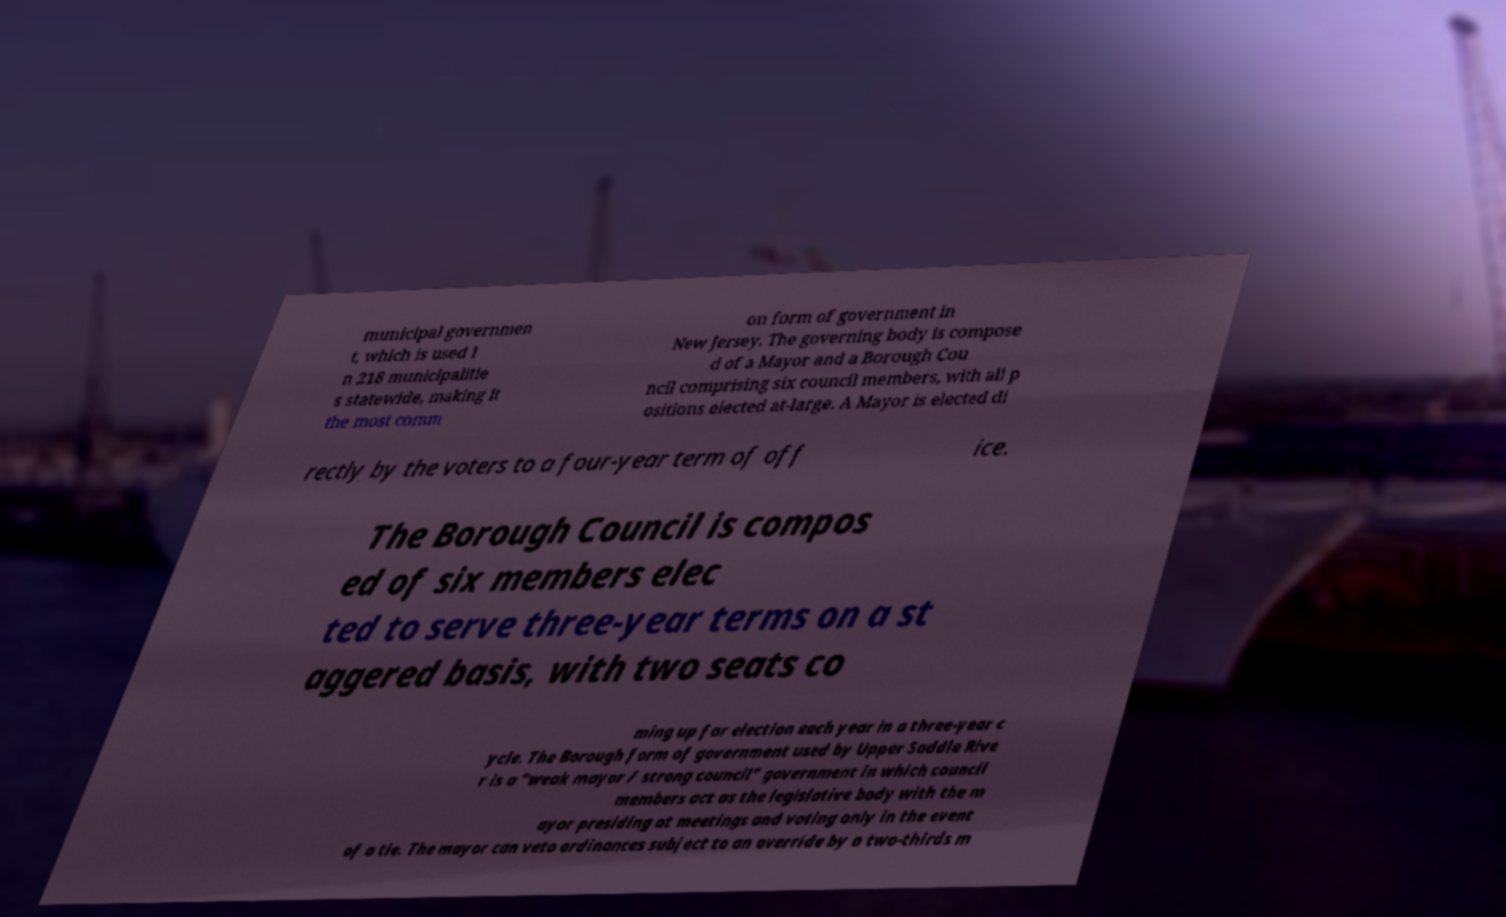What messages or text are displayed in this image? I need them in a readable, typed format. municipal governmen t, which is used i n 218 municipalitie s statewide, making it the most comm on form of government in New Jersey. The governing body is compose d of a Mayor and a Borough Cou ncil comprising six council members, with all p ositions elected at-large. A Mayor is elected di rectly by the voters to a four-year term of off ice. The Borough Council is compos ed of six members elec ted to serve three-year terms on a st aggered basis, with two seats co ming up for election each year in a three-year c ycle. The Borough form of government used by Upper Saddle Rive r is a "weak mayor / strong council" government in which council members act as the legislative body with the m ayor presiding at meetings and voting only in the event of a tie. The mayor can veto ordinances subject to an override by a two-thirds m 